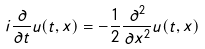Convert formula to latex. <formula><loc_0><loc_0><loc_500><loc_500>i \frac { \partial } { \partial t } u ( t , x ) = - \frac { 1 } { 2 } \frac { \partial ^ { 2 } } { \partial x ^ { 2 } } u ( t , x )</formula> 